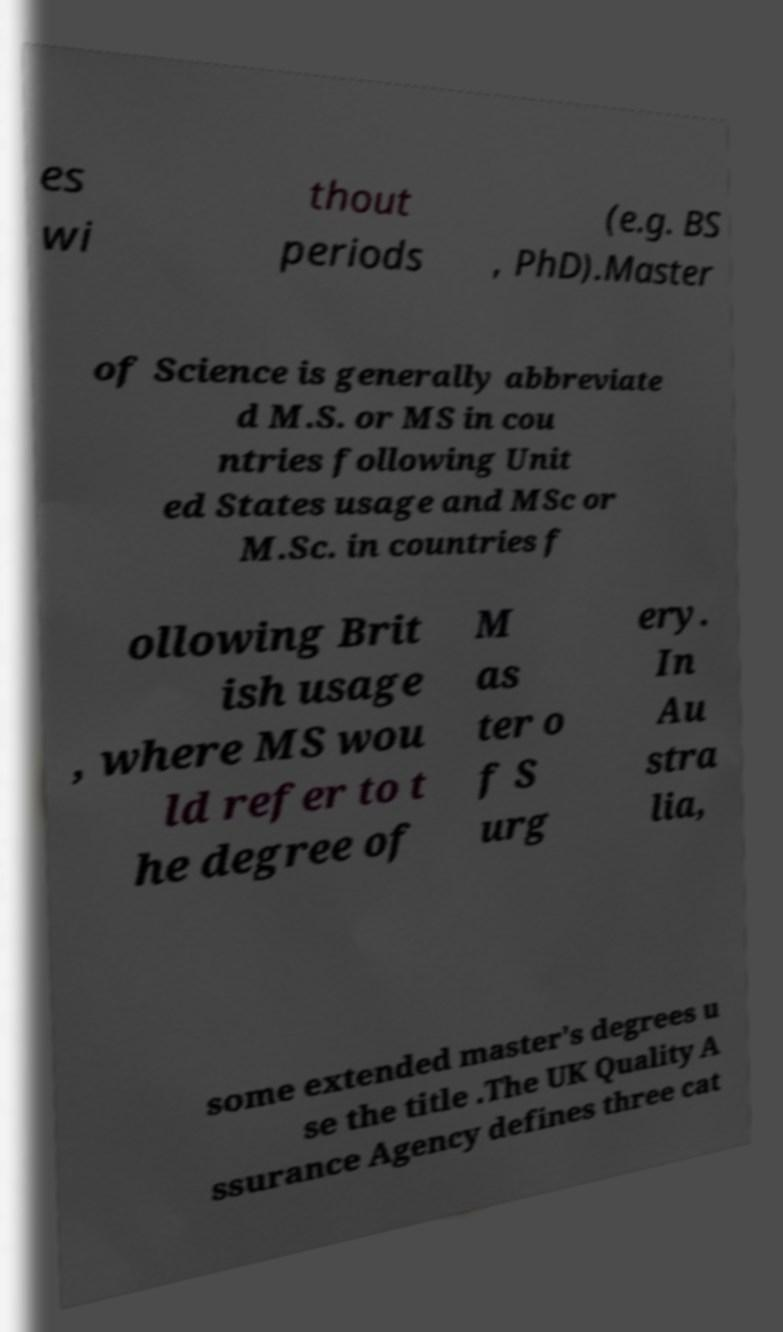Could you extract and type out the text from this image? es wi thout periods (e.g. BS , PhD).Master of Science is generally abbreviate d M.S. or MS in cou ntries following Unit ed States usage and MSc or M.Sc. in countries f ollowing Brit ish usage , where MS wou ld refer to t he degree of M as ter o f S urg ery. In Au stra lia, some extended master's degrees u se the title .The UK Quality A ssurance Agency defines three cat 